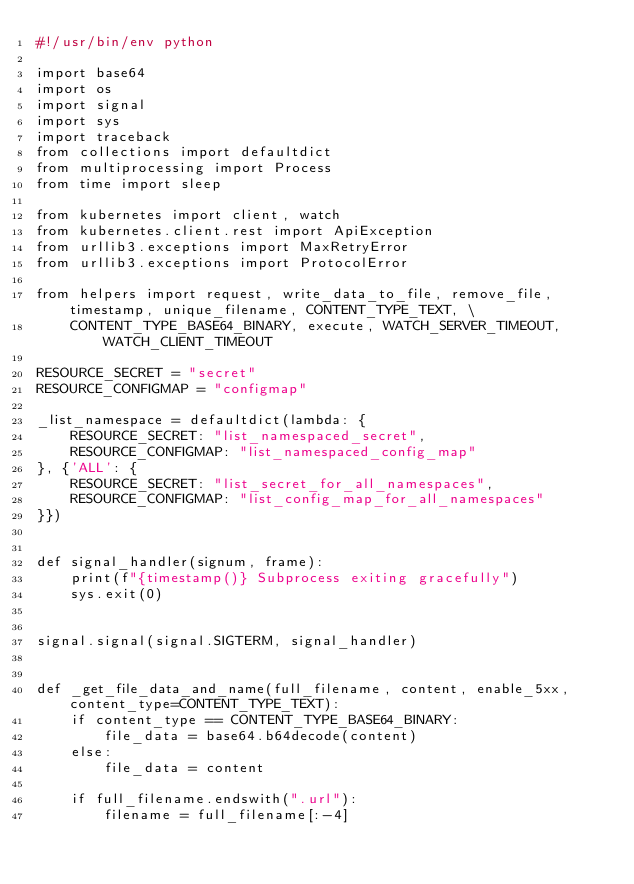<code> <loc_0><loc_0><loc_500><loc_500><_Python_>#!/usr/bin/env python

import base64
import os
import signal
import sys
import traceback
from collections import defaultdict
from multiprocessing import Process
from time import sleep

from kubernetes import client, watch
from kubernetes.client.rest import ApiException
from urllib3.exceptions import MaxRetryError
from urllib3.exceptions import ProtocolError

from helpers import request, write_data_to_file, remove_file, timestamp, unique_filename, CONTENT_TYPE_TEXT, \
    CONTENT_TYPE_BASE64_BINARY, execute, WATCH_SERVER_TIMEOUT, WATCH_CLIENT_TIMEOUT

RESOURCE_SECRET = "secret"
RESOURCE_CONFIGMAP = "configmap"

_list_namespace = defaultdict(lambda: {
    RESOURCE_SECRET: "list_namespaced_secret",
    RESOURCE_CONFIGMAP: "list_namespaced_config_map"
}, {'ALL': {
    RESOURCE_SECRET: "list_secret_for_all_namespaces",
    RESOURCE_CONFIGMAP: "list_config_map_for_all_namespaces"
}})


def signal_handler(signum, frame):
    print(f"{timestamp()} Subprocess exiting gracefully")
    sys.exit(0)


signal.signal(signal.SIGTERM, signal_handler)


def _get_file_data_and_name(full_filename, content, enable_5xx, content_type=CONTENT_TYPE_TEXT):
    if content_type == CONTENT_TYPE_BASE64_BINARY:
        file_data = base64.b64decode(content)
    else:
        file_data = content

    if full_filename.endswith(".url"):
        filename = full_filename[:-4]</code> 